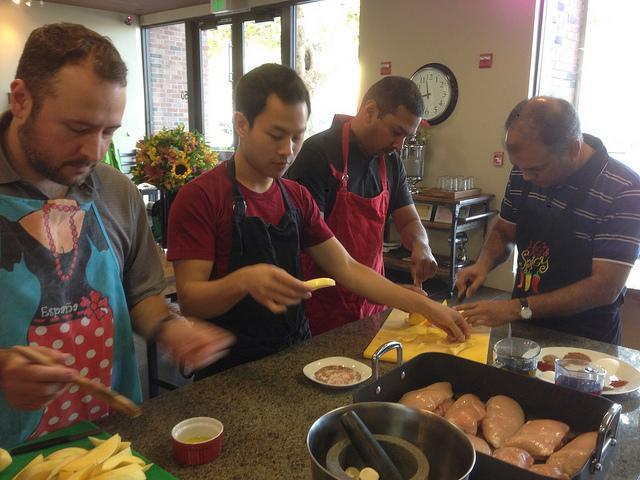How many men at the table?
Give a very brief answer. 4. How many people are there?
Give a very brief answer. 4. How many bowls are visible?
Give a very brief answer. 2. 